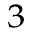<formula> <loc_0><loc_0><loc_500><loc_500>_ { 3 }</formula> 